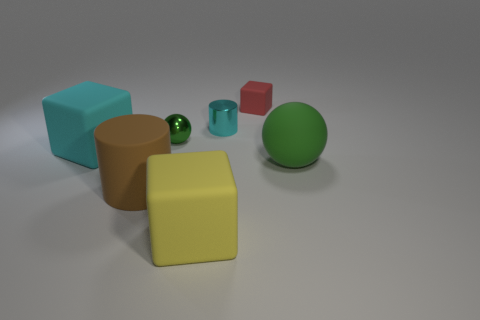What color is the other shiny thing that is the same shape as the brown thing? cyan 